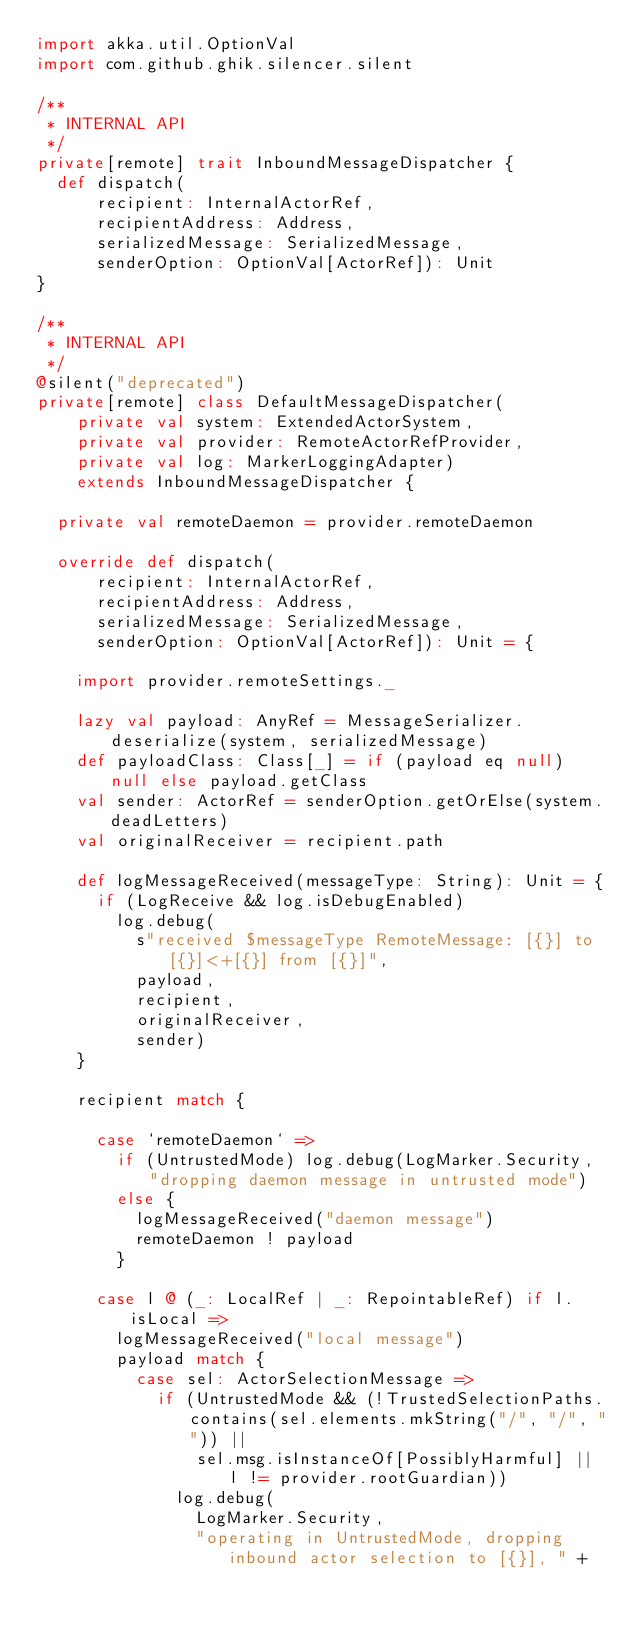<code> <loc_0><loc_0><loc_500><loc_500><_Scala_>import akka.util.OptionVal
import com.github.ghik.silencer.silent

/**
 * INTERNAL API
 */
private[remote] trait InboundMessageDispatcher {
  def dispatch(
      recipient: InternalActorRef,
      recipientAddress: Address,
      serializedMessage: SerializedMessage,
      senderOption: OptionVal[ActorRef]): Unit
}

/**
 * INTERNAL API
 */
@silent("deprecated")
private[remote] class DefaultMessageDispatcher(
    private val system: ExtendedActorSystem,
    private val provider: RemoteActorRefProvider,
    private val log: MarkerLoggingAdapter)
    extends InboundMessageDispatcher {

  private val remoteDaemon = provider.remoteDaemon

  override def dispatch(
      recipient: InternalActorRef,
      recipientAddress: Address,
      serializedMessage: SerializedMessage,
      senderOption: OptionVal[ActorRef]): Unit = {

    import provider.remoteSettings._

    lazy val payload: AnyRef = MessageSerializer.deserialize(system, serializedMessage)
    def payloadClass: Class[_] = if (payload eq null) null else payload.getClass
    val sender: ActorRef = senderOption.getOrElse(system.deadLetters)
    val originalReceiver = recipient.path

    def logMessageReceived(messageType: String): Unit = {
      if (LogReceive && log.isDebugEnabled)
        log.debug(
          s"received $messageType RemoteMessage: [{}] to [{}]<+[{}] from [{}]",
          payload,
          recipient,
          originalReceiver,
          sender)
    }

    recipient match {

      case `remoteDaemon` =>
        if (UntrustedMode) log.debug(LogMarker.Security, "dropping daemon message in untrusted mode")
        else {
          logMessageReceived("daemon message")
          remoteDaemon ! payload
        }

      case l @ (_: LocalRef | _: RepointableRef) if l.isLocal =>
        logMessageReceived("local message")
        payload match {
          case sel: ActorSelectionMessage =>
            if (UntrustedMode && (!TrustedSelectionPaths.contains(sel.elements.mkString("/", "/", "")) ||
                sel.msg.isInstanceOf[PossiblyHarmful] || l != provider.rootGuardian))
              log.debug(
                LogMarker.Security,
                "operating in UntrustedMode, dropping inbound actor selection to [{}], " +</code> 